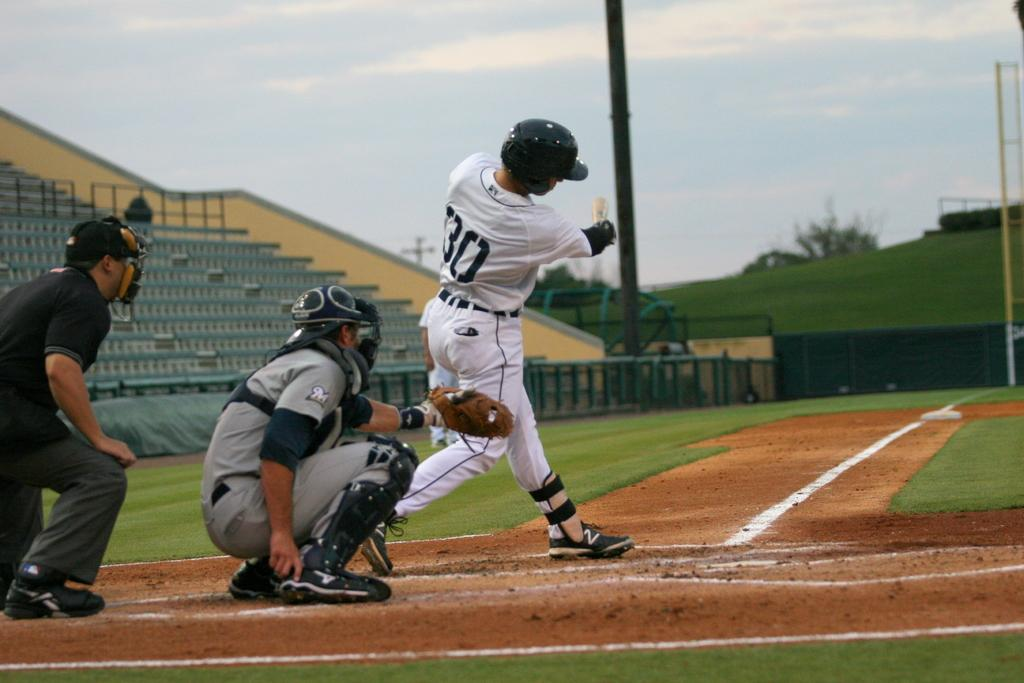Provide a one-sentence caption for the provided image. The batter in the number 30 uniform has just taken a swing at the ball. 